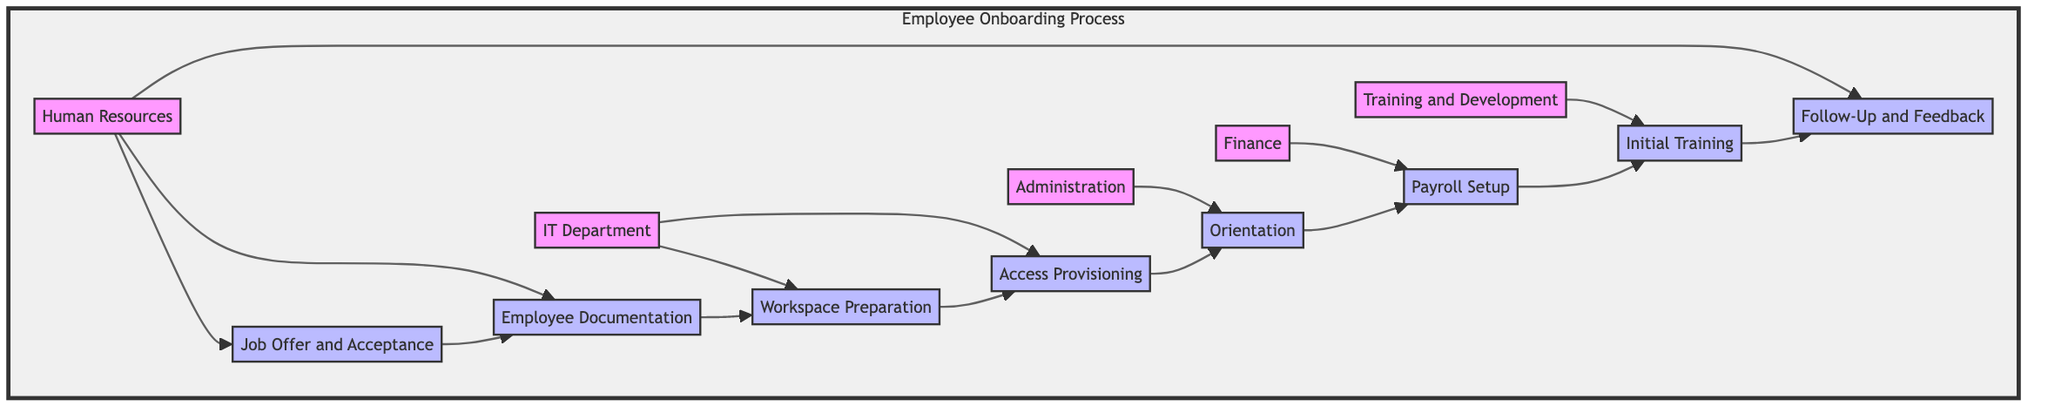What is the first step in the onboarding process? The first step listed in the diagram is "Job Offer and Acceptance," which is the starting point for onboarding an employee. It is associated with the Human Resources department.
Answer: Job Offer and Acceptance Which department is responsible for payroll setup? The diagram indicates that the "Finance" department handles the "Payroll Setup" step, meaning they are responsible for setting up the new employee's payroll and benefits information.
Answer: Finance How many departments are involved in the employee onboarding process? The diagram shows five departments: Human Resources, IT Department, Administration, Finance, and Training and Development. Counting these departments provides the total number involved in the onboarding process.
Answer: Five What follows the "Employee Documentation" step? According to the flow in the diagram, "Workspace Preparation" follows after "Employee Documentation," demonstrating the order of steps in the onboarding process.
Answer: Workspace Preparation Which department handles the orientation? The orientation step is managed by the Administration department as indicated in the diagram, where it is linked to the "Orientation" step.
Answer: Administration How many steps are there in the onboarding process? The diagram lists eight distinct steps from "Job Offer and Acceptance" to "Follow-Up and Feedback," indicating that there are a total of eight steps in the onboarding process.
Answer: Eight What provides access to necessary company systems? The "Access Provisioning" step, which is managed by the IT Department, is responsible for providing access to necessary company systems, email, and tools as shown in the diagram.
Answer: Access Provisioning Which step is the last in the process? The last step in the onboarding process, as illustrated in the diagram, is "Follow-Up and Feedback," signifying the concluding actions taken after the initial onboarding.
Answer: Follow-Up and Feedback Which two departments are involved in the setup of the workspace? The diagram shows that the IT Department is primarily responsible for "Workspace Preparation" and "Access Provisioning," indicating their involvement in setting up the workspace for the new employee.
Answer: IT Department 